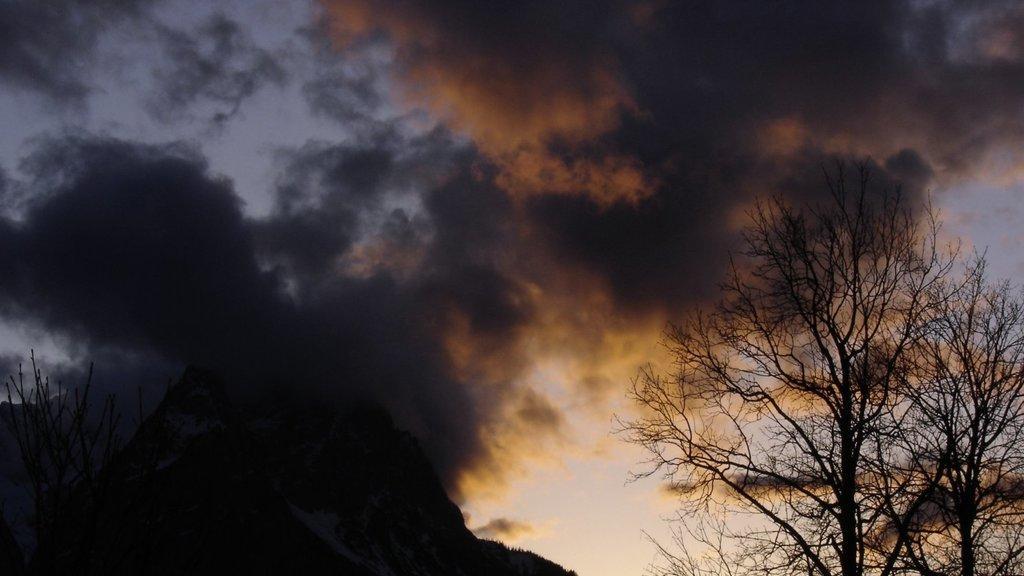Can you describe this image briefly? On the right side, we see the trees. At the bottom, we see a hill and the trees. In the background, we see the clouds and the sky. 